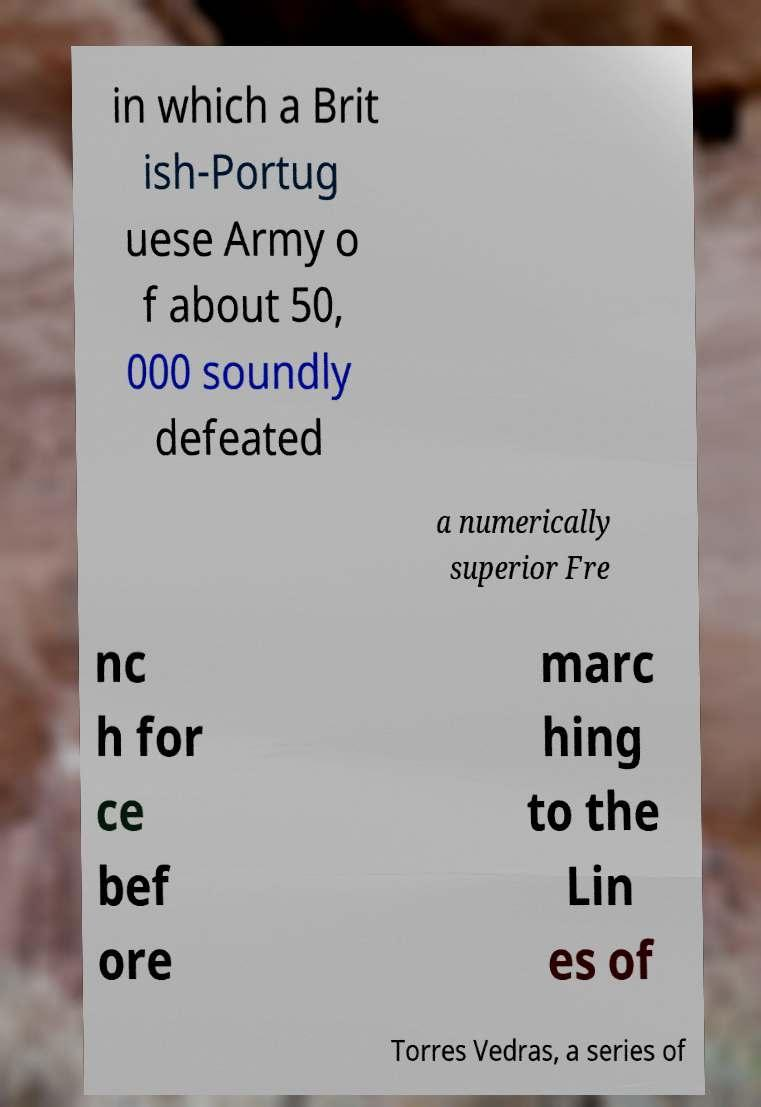Can you accurately transcribe the text from the provided image for me? in which a Brit ish-Portug uese Army o f about 50, 000 soundly defeated a numerically superior Fre nc h for ce bef ore marc hing to the Lin es of Torres Vedras, a series of 